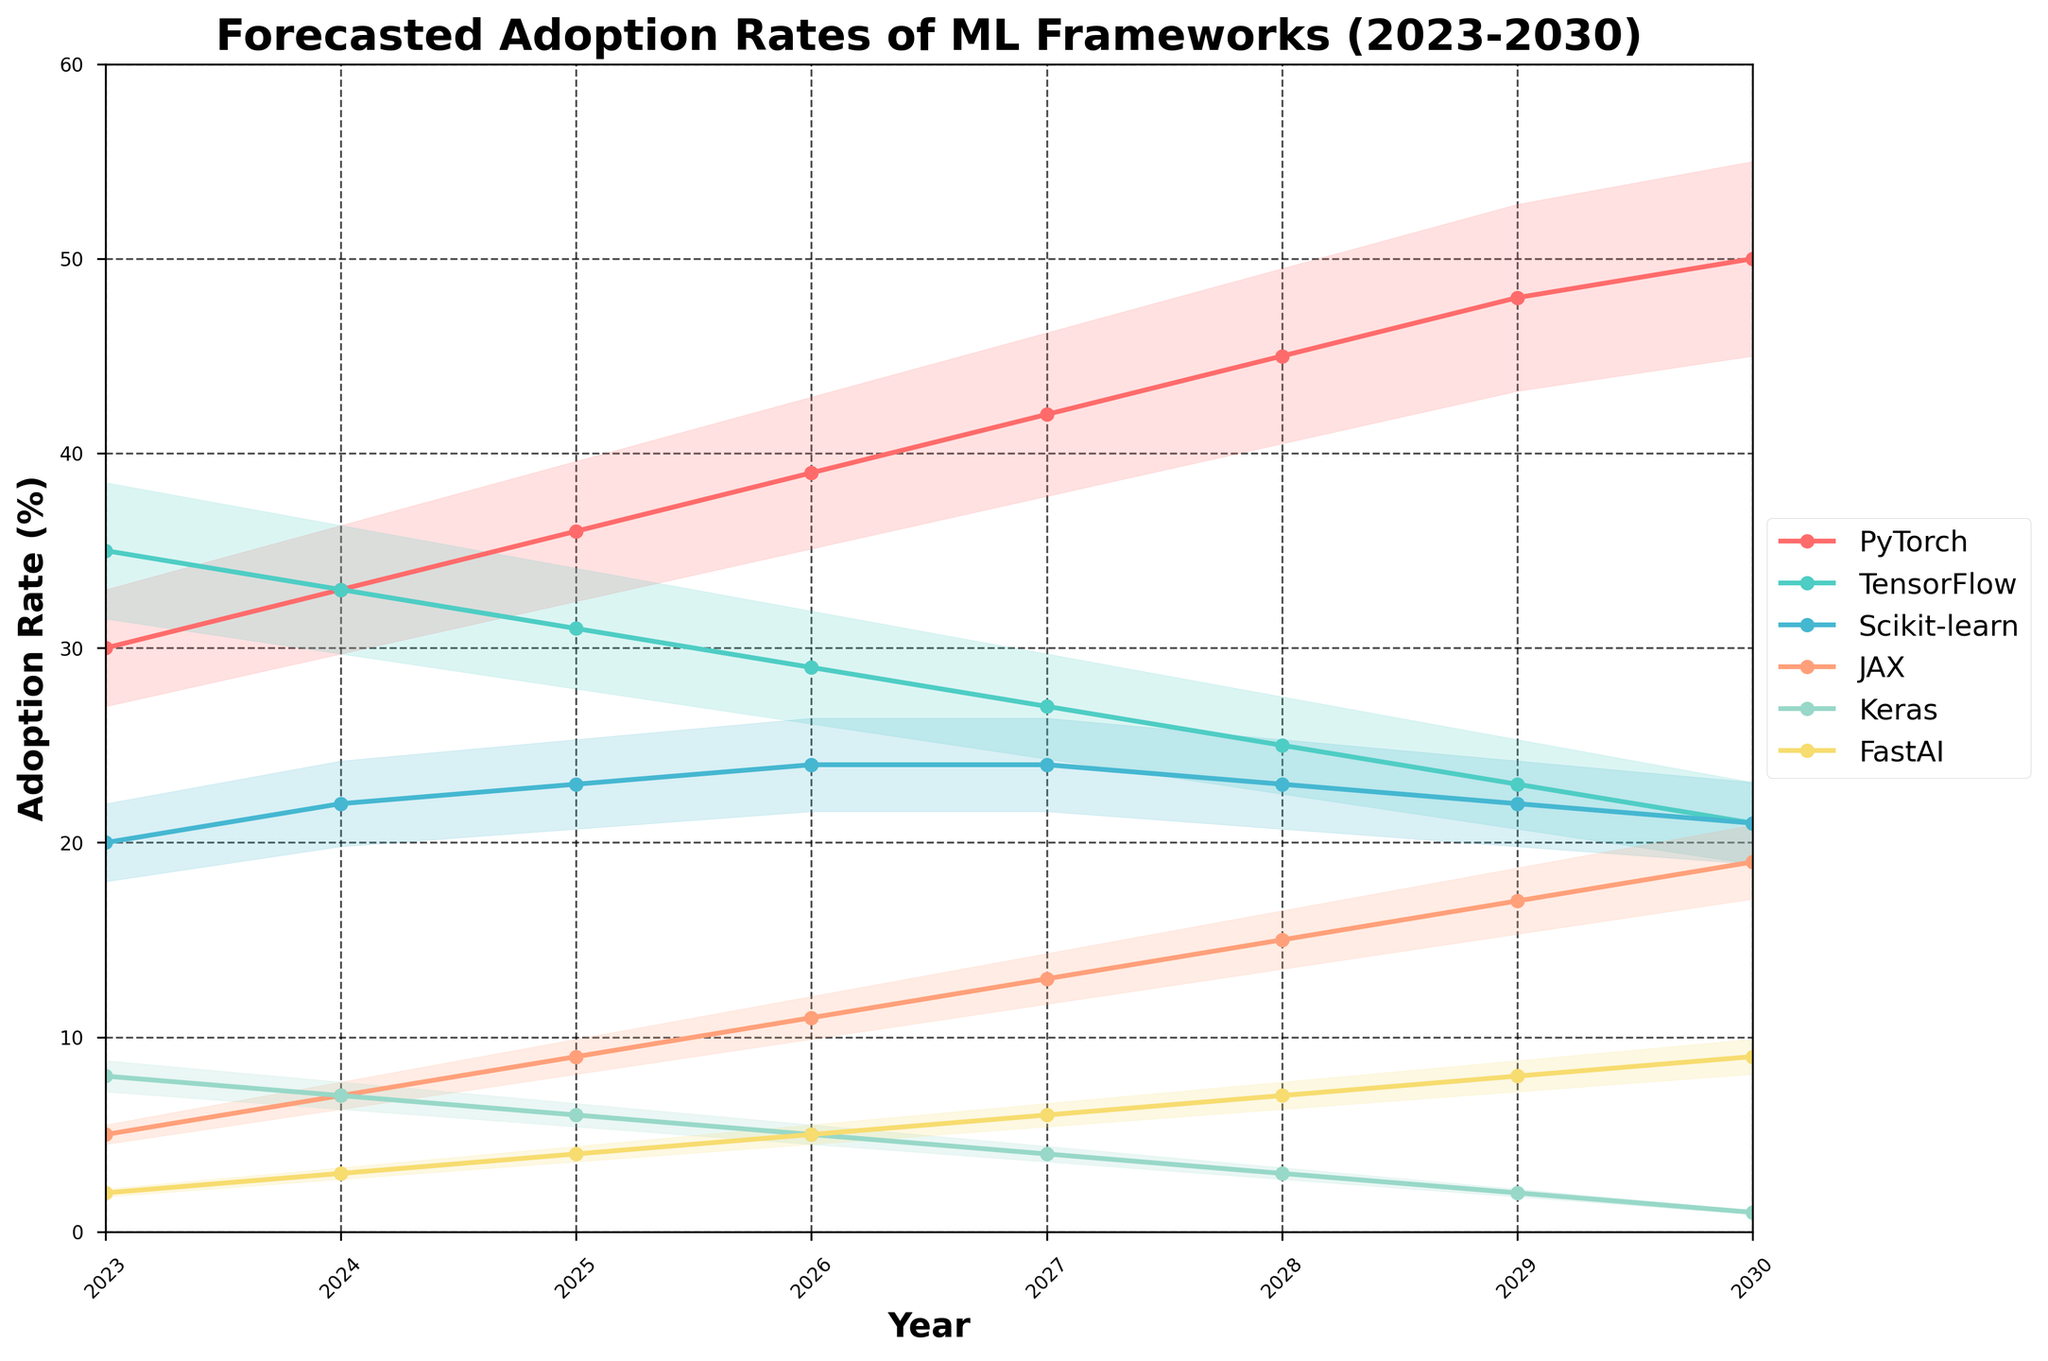Which ML framework is forecasted to have the highest adoption rate in 2030? Look at the endpoints for the year 2030 for each framework. PyTorch is at 50%, which is the highest.
Answer: PyTorch How does the adoption rate of TensorFlow change from 2023 to 2030? Compare the values of TensorFlow at both endpoints. It drops from 35% in 2023 to 21% in 2030.
Answer: Decreases What is the cumulative increase in the adoption rate for JAX from 2023 to 2030? Subtract the adoption rate of JAX in 2023 from its adoption rate in 2030. (19% - 5%)
Answer: 14% Which framework shows the least variation in adoption rates between 2023 and 2030? Examine the filled areas (confidence intervals) to see which framework has the smallest change. Scikit-learn seems to have the least variation with slight up and down movements around 20-24%.
Answer: Scikit-learn Are there any frameworks that show a consistent increase in adoption rates from 2023 to 2030? Look for frameworks with a steady upward trend. PyTorch, JAX, and FastAI all show consistent increases.
Answer: PyTorch, JAX, FastAI Which frameworks have a declining adoption rate between 2023 and 2030? Identify the frameworks where the lines trend downward. TensorFlow and Keras are both declining.
Answer: TensorFlow, Keras What is the net change in the adoption rate for Keras from 2024 to 2028? Subtract the adoption rate in 2024 from the adoption rate in 2028. (3% - 7%)
Answer: -4% Between 2025 and 2026, which framework has the highest increase in adoption rate? Calculate the differences between 2025 and 2026 for all frameworks. PyTorch increases by 3% (39%-36%).
Answer: PyTorch On which year do PyTorch and TensorFlow have the same adoption rate? Compare the adoption rates for both frameworks. They are the same in 2024 at 33%.
Answer: 2024 Out of all the frameworks, which one has the lowest adoption rate in 2023 and does this change by 2030? Look at the values in 2023 and 2030. FastAI has the lowest at 2% in 2023, but it increases to 9% by 2030.
Answer: FastAI, Yes 